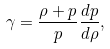<formula> <loc_0><loc_0><loc_500><loc_500>\gamma = \frac { \rho + p } { p } \frac { d p } { d \rho } ,</formula> 